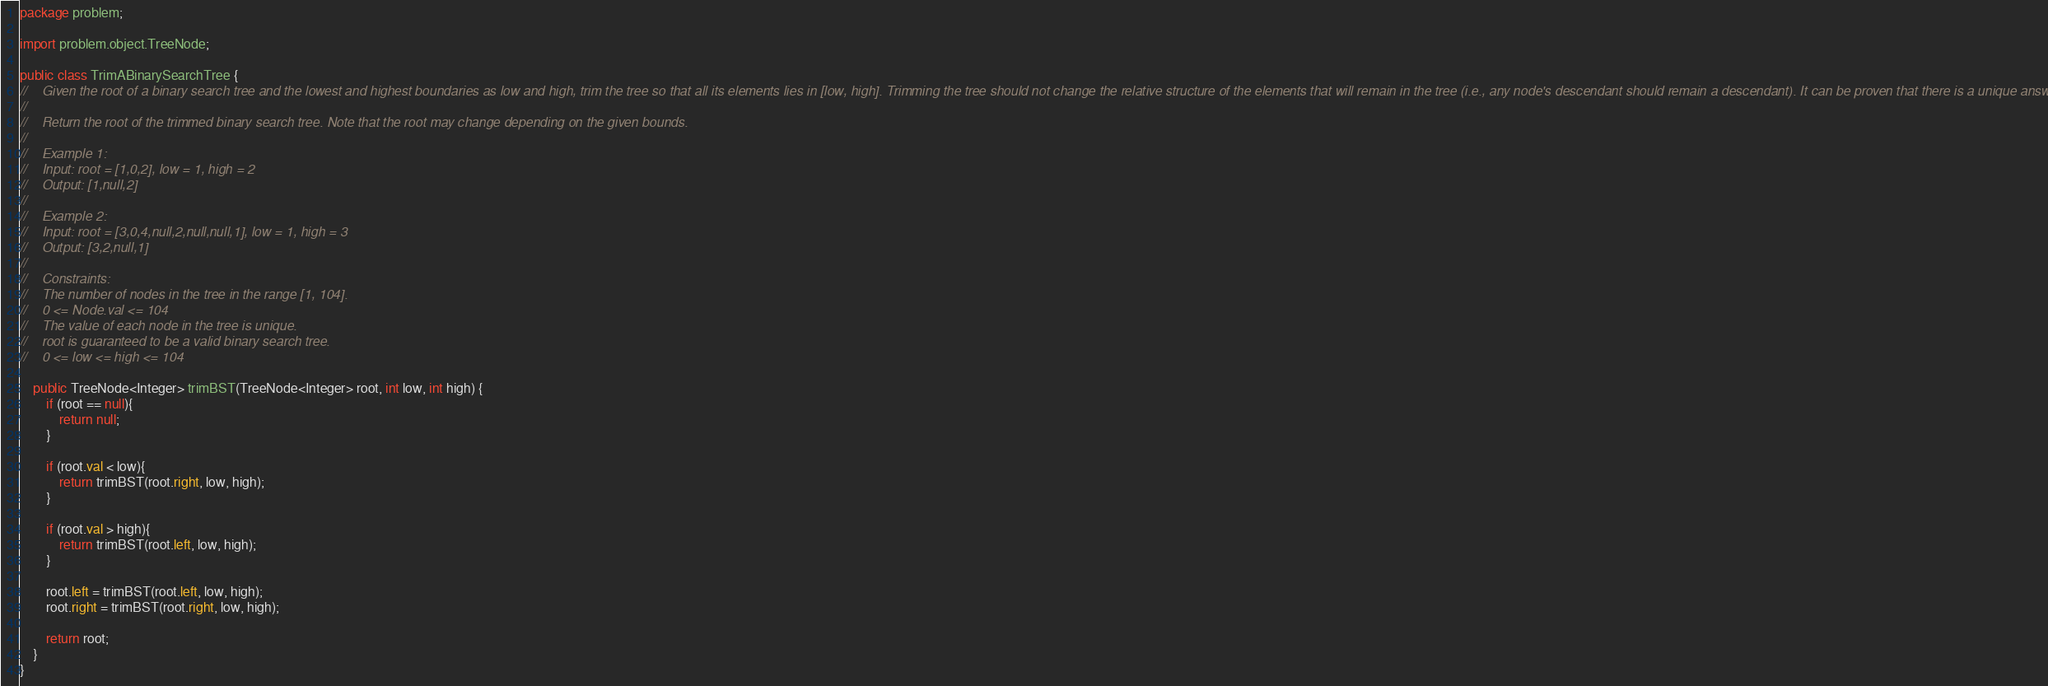<code> <loc_0><loc_0><loc_500><loc_500><_Java_>package problem;

import problem.object.TreeNode;

public class TrimABinarySearchTree {
//    Given the root of a binary search tree and the lowest and highest boundaries as low and high, trim the tree so that all its elements lies in [low, high]. Trimming the tree should not change the relative structure of the elements that will remain in the tree (i.e., any node's descendant should remain a descendant). It can be proven that there is a unique answer.
//
//    Return the root of the trimmed binary search tree. Note that the root may change depending on the given bounds.
//
//    Example 1:
//    Input: root = [1,0,2], low = 1, high = 2
//    Output: [1,null,2]
//
//    Example 2:
//    Input: root = [3,0,4,null,2,null,null,1], low = 1, high = 3
//    Output: [3,2,null,1]
//
//    Constraints:
//    The number of nodes in the tree in the range [1, 104].
//    0 <= Node.val <= 104
//    The value of each node in the tree is unique.
//    root is guaranteed to be a valid binary search tree.
//    0 <= low <= high <= 104

    public TreeNode<Integer> trimBST(TreeNode<Integer> root, int low, int high) {
        if (root == null){
            return null;
        }

        if (root.val < low){
            return trimBST(root.right, low, high);
        }

        if (root.val > high){
            return trimBST(root.left, low, high);
        }

        root.left = trimBST(root.left, low, high);
        root.right = trimBST(root.right, low, high);

        return root;
    }
}
</code> 